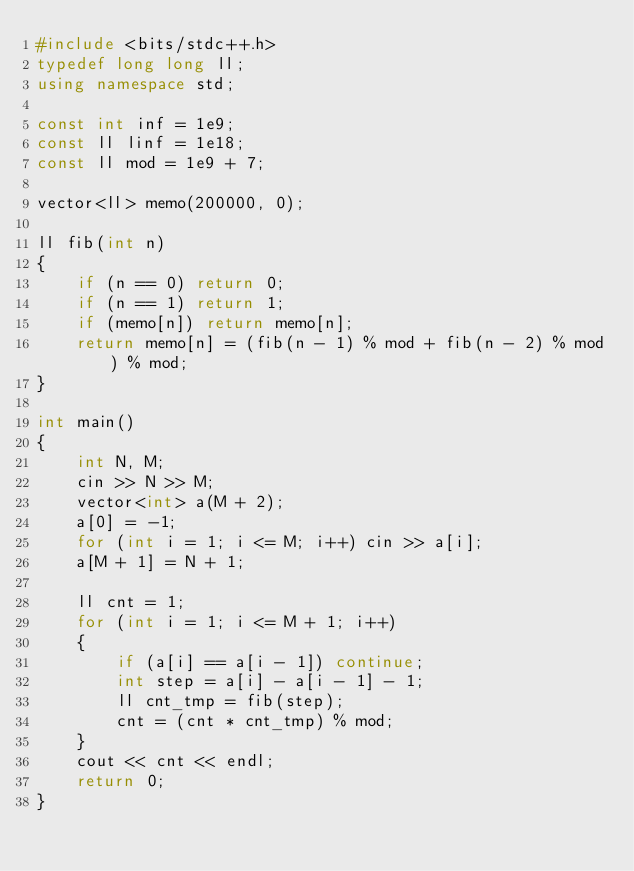Convert code to text. <code><loc_0><loc_0><loc_500><loc_500><_C++_>#include <bits/stdc++.h>
typedef long long ll;
using namespace std;

const int inf = 1e9;
const ll linf = 1e18;
const ll mod = 1e9 + 7;

vector<ll> memo(200000, 0);

ll fib(int n)
{
    if (n == 0) return 0;
    if (n == 1) return 1;
    if (memo[n]) return memo[n];
    return memo[n] = (fib(n - 1) % mod + fib(n - 2) % mod) % mod;
}

int main()
{
    int N, M;
    cin >> N >> M;
    vector<int> a(M + 2);
    a[0] = -1;
    for (int i = 1; i <= M; i++) cin >> a[i];
    a[M + 1] = N + 1;

    ll cnt = 1;
    for (int i = 1; i <= M + 1; i++)
    {
        if (a[i] == a[i - 1]) continue;
        int step = a[i] - a[i - 1] - 1;
        ll cnt_tmp = fib(step);
        cnt = (cnt * cnt_tmp) % mod;
    }
    cout << cnt << endl;
    return 0;
}</code> 